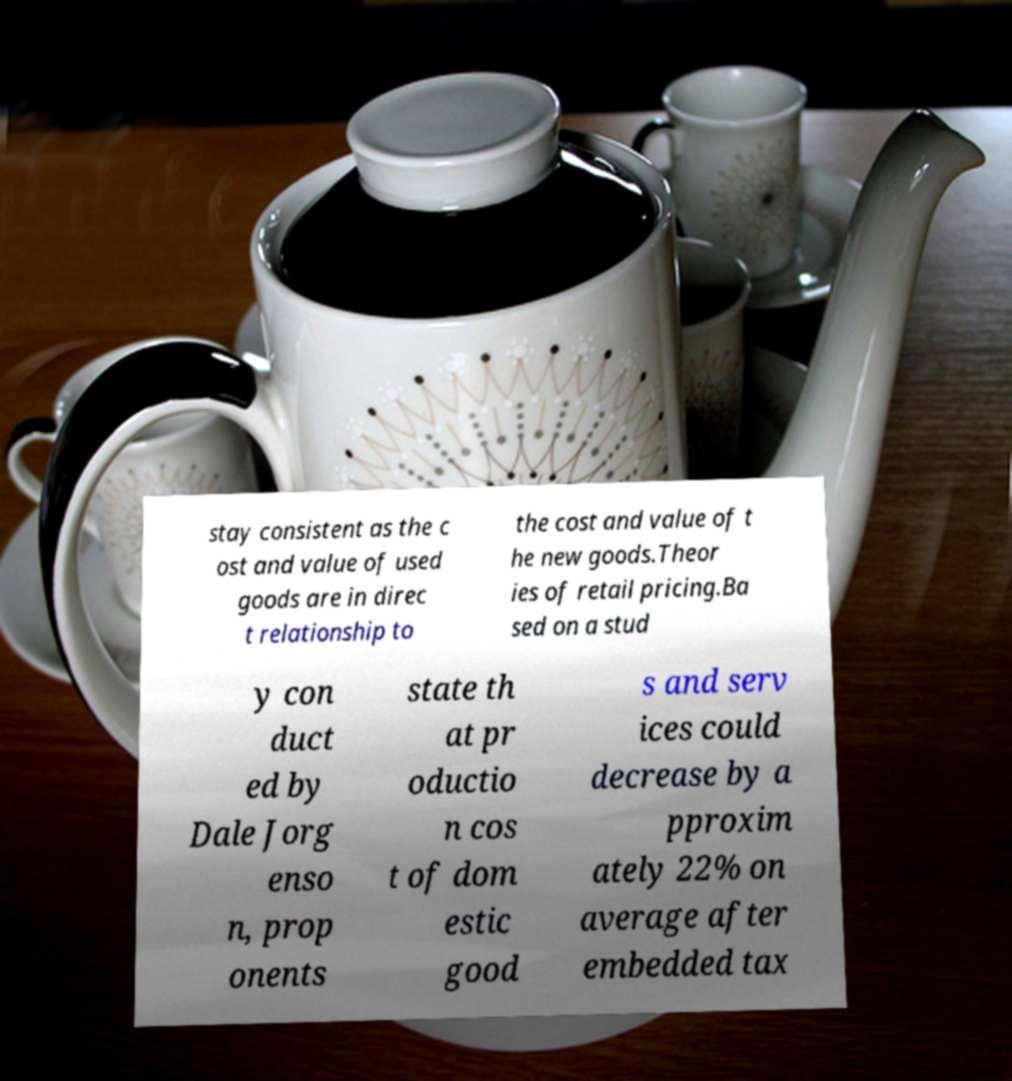Can you read and provide the text displayed in the image?This photo seems to have some interesting text. Can you extract and type it out for me? stay consistent as the c ost and value of used goods are in direc t relationship to the cost and value of t he new goods.Theor ies of retail pricing.Ba sed on a stud y con duct ed by Dale Jorg enso n, prop onents state th at pr oductio n cos t of dom estic good s and serv ices could decrease by a pproxim ately 22% on average after embedded tax 